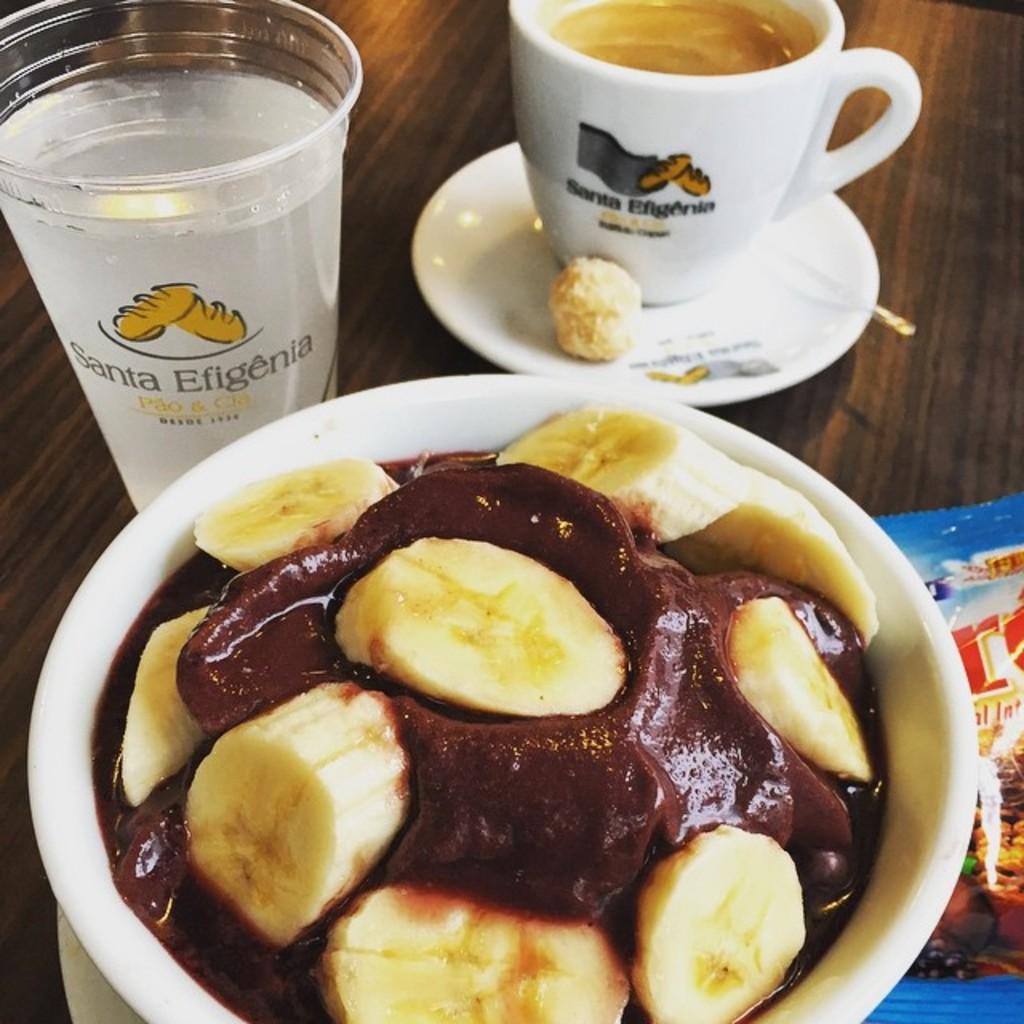Could you give a brief overview of what you see in this image? In this image there is a bowl on the surface, there is food in the bowl, there is an object truncated towards the right of the image, there is a glass, there is text on the glass, there is a saucer on the surface, there are objects on the saucer, there is a cup truncated, there is a cup on the saucer, there is a drink in the cup. 